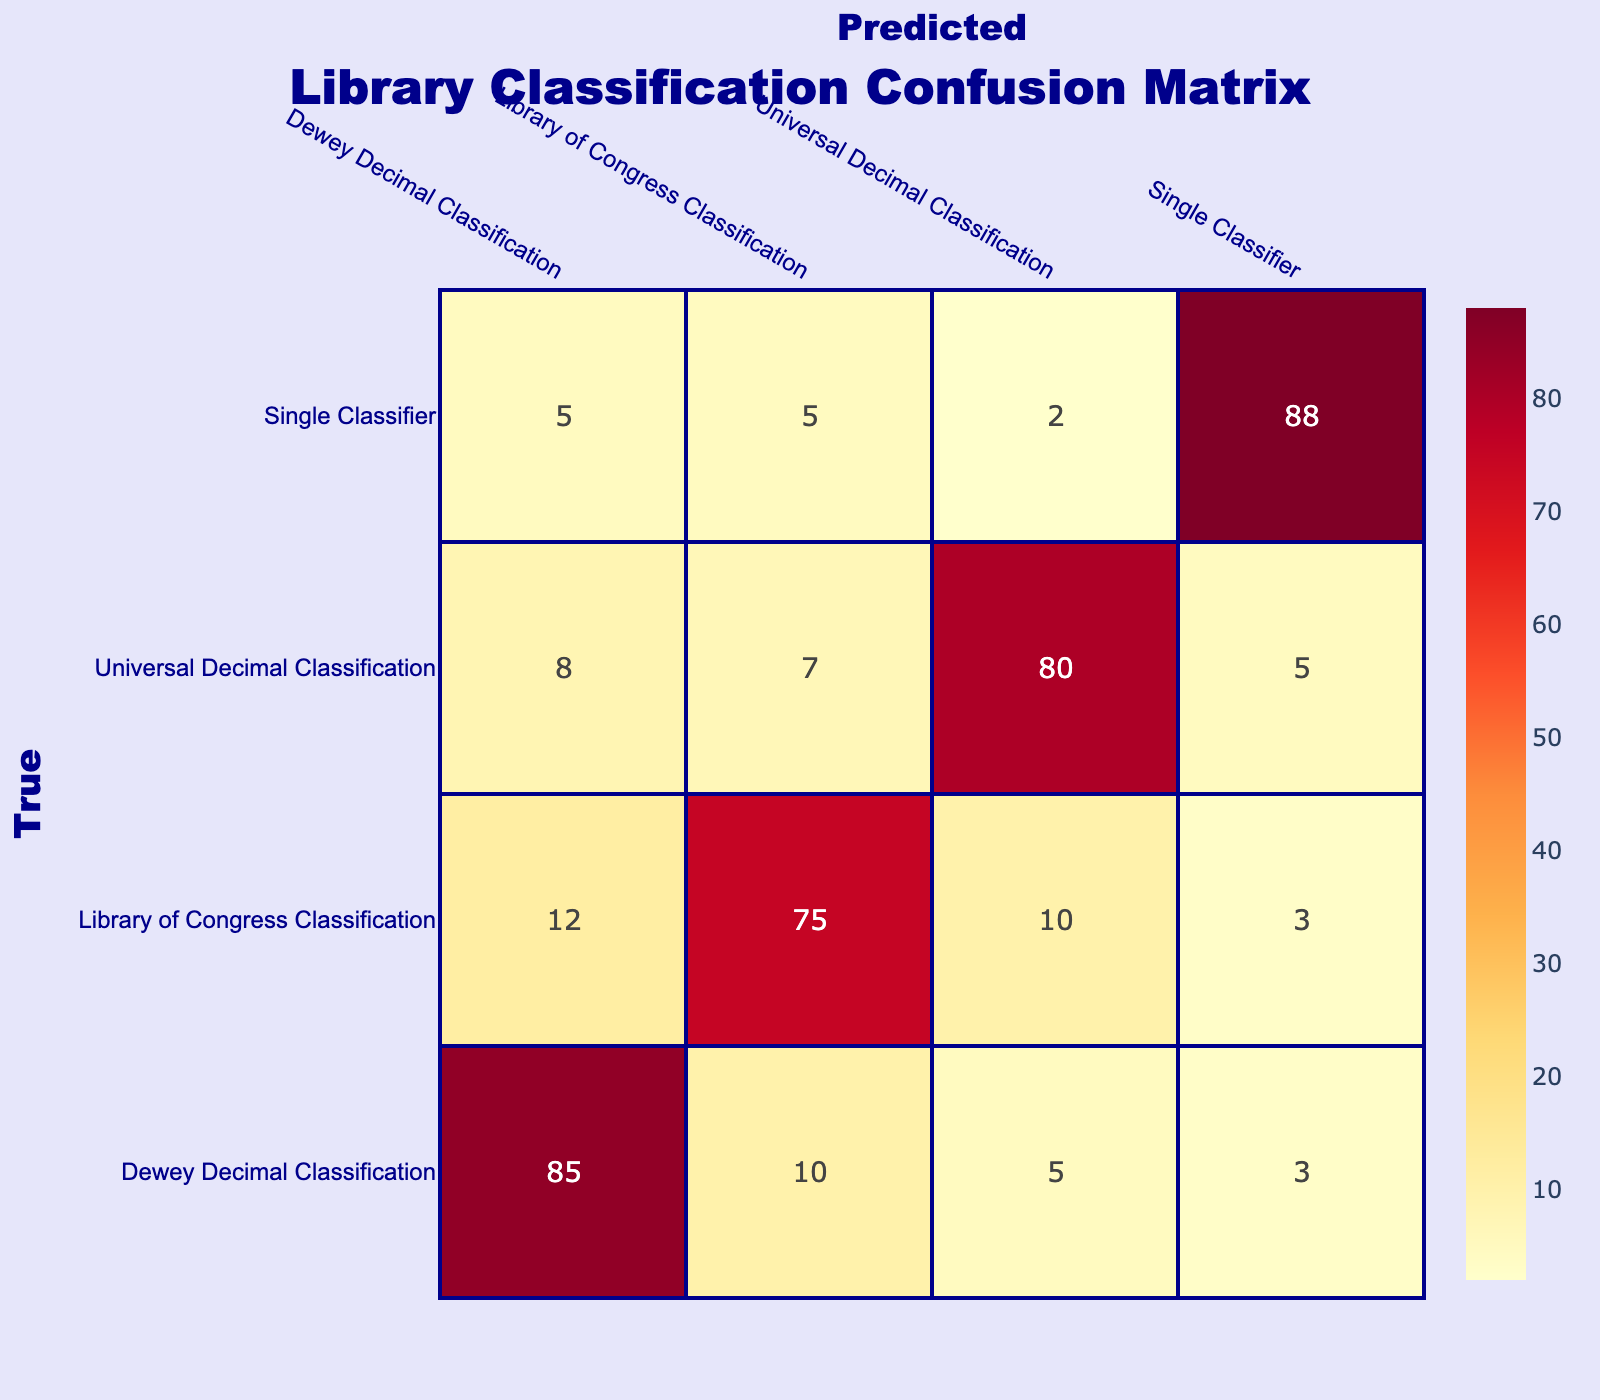What is the predicted classification accuracy for Dewey Decimal Classification? Looking at the table, the predicted value for Dewey Decimal Classification is 85.
Answer: 85 What is the count of misclassified entries for the Library of Congress Classification? To find the misclassified entries for Library of Congress Classification, we can sum the values in its row excluding the true classification. The values are 12 (Dewey), 10 (UDC), and 3 (single), thus 12 + 10 + 3 = 25.
Answer: 25 Is the Universal Decimal Classification more accurately classified than the Library of Congress Classification? The total accurate predictions for Universal Decimal Classification are 80, while for Library of Congress Classification it is 75. Since 80 is greater than 75, it is true.
Answer: Yes What is the total number of total misclassifications across all classification systems? We can sum up all false predictions across the entire confusion matrix. The false predictions are 10 + 5 + 12 + 10 + 8 + 7 + 5 + 2 = 69.
Answer: 69 What is the average count of predictions made for each cataloging system? We look at the total counts in the first column (Dewey = 103, LOC = 100, UDC = 100, Single Classifier = 100), summing these gives us 403. Since there are four categories, we divide by 4, so 403/4 = 100.75.
Answer: 100.75 What is the highest single entry prediction in the table and which classification does it correspond to? The highest entry in the table is 88, which corresponds to the Single Classifier.
Answer: 88; Single Classifier How many predictions were made using the Single Classifier for Dewey Decimal Classification? The entry for Dewey Decimal Classification under Single Classifier is 5, which indicates that 5 predictions were made for that classification.
Answer: 5 What is the total count of correct classifications across all systems? The correct classifications are the diagonal entries of the table: 85 + 75 + 80 + 88 = 328. Therefore, the total count of correct classifications is 328.
Answer: 328 